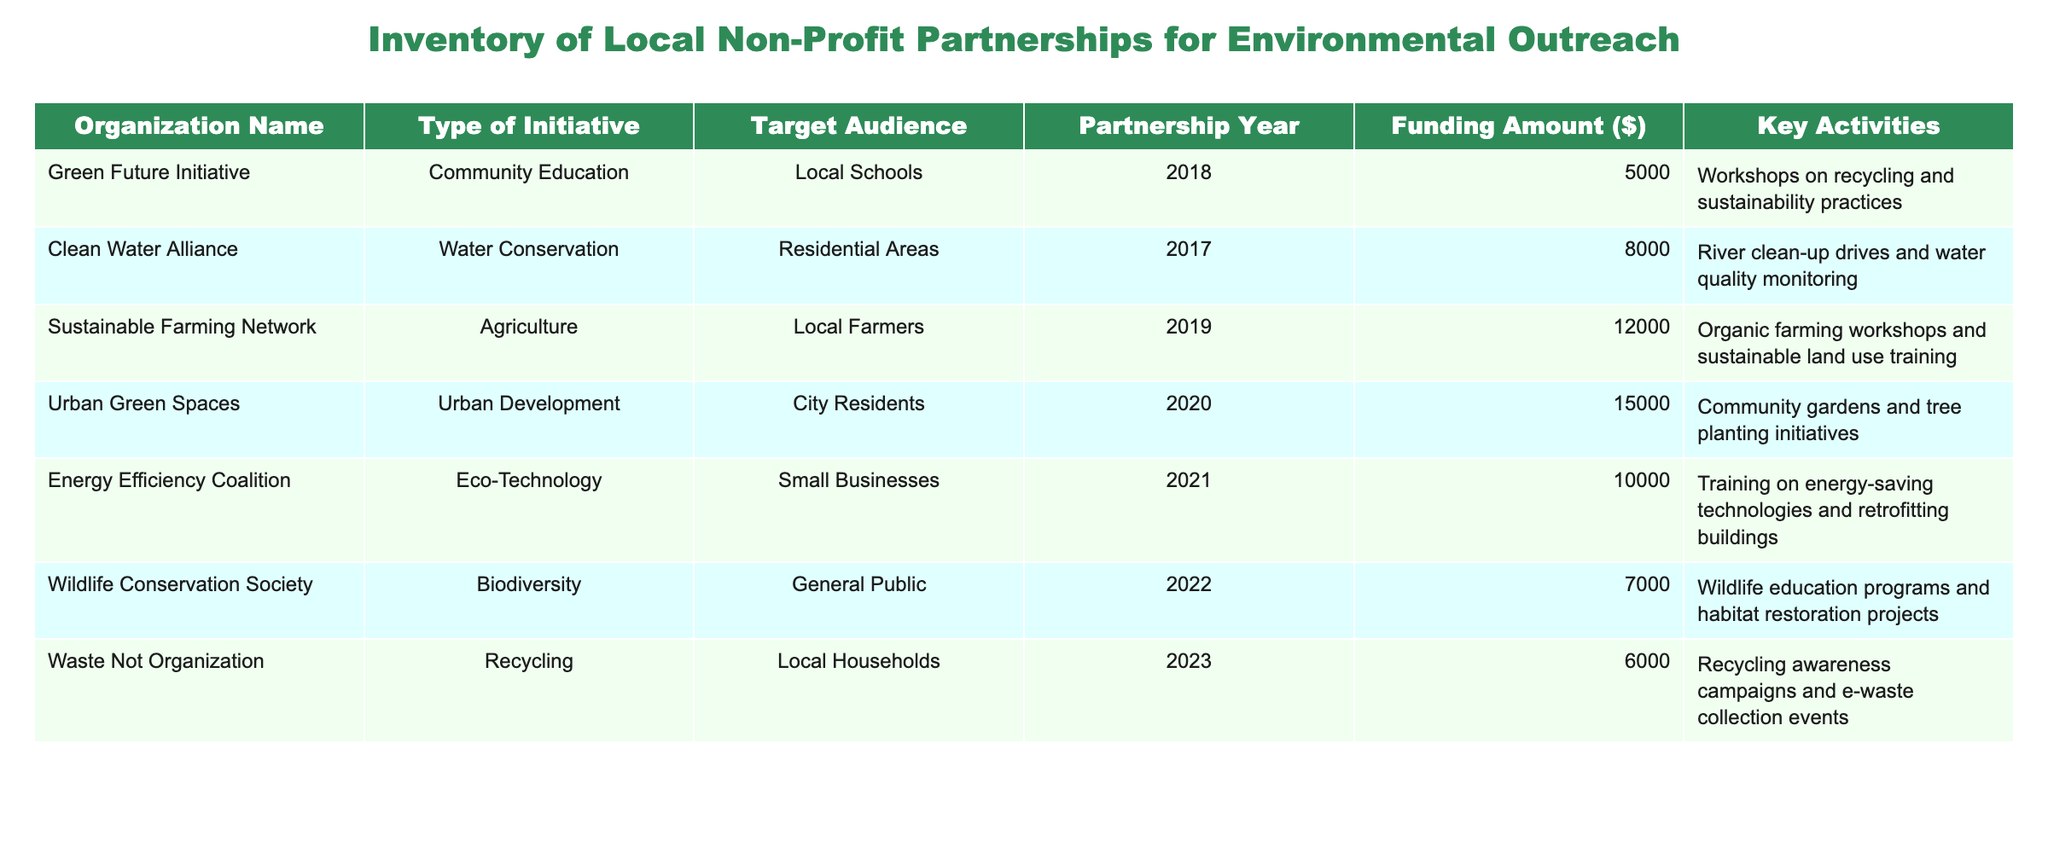What type of initiative does the Sustainable Farming Network focus on? The table lists the types of initiatives under the "Type of Initiative" column. Looking for "Sustainable Farming Network," I see that its initiative is categorized as "Agriculture."
Answer: Agriculture Which organization received the highest funding amount? By examining the "Funding Amount ($)" column, Urban Green Spaces has the highest amount at 15000, which is greater than the amounts for the other organizations listed.
Answer: Urban Green Spaces How many organizations focus on community education? Checking the table under the "Type of Initiative" column, I find only one organization, the Green Future Initiative, which focuses on "Community Education."
Answer: 1 What is the average funding amount for all organizations listed? To find the average, first, sum the funding amounts: 5000 + 8000 + 12000 + 15000 + 10000 + 7000 + 6000 = 60000. Then divide by the number of organizations (7): 60000 / 7 = 8571.43.
Answer: 8571.43 Did any organization partner in 2022? Scanning the "Partnership Year" column, I find that the Wildlife Conservation Society partnered in 2022, confirming that an organization did indeed partner that year.
Answer: Yes Which target audience was addressed by the Clean Water Alliance? Referring to the "Target Audience" column while finding "Clean Water Alliance," it is listed as targeting "Residential Areas."
Answer: Residential Areas What are the key activities of the Waste Not Organization? Looking at the Key Activities column for the Waste Not Organization, it mentions "Recycling awareness campaigns and e-waste collection events," which describes its actions.
Answer: Recycling awareness campaigns and e-waste collection events Is there an organization focusing on eco-technology initiatives? Checking the "Type of Initiative" column, I see that the Energy Efficiency Coalition is listed under "Eco-Technology," indicating that there is an organization with this focus.
Answer: Yes What is the total funding received by initiatives focused on environmental education? First, identify relevant initiatives: Green Future Initiative ($5000) and Wildlife Conservation Society ($7000). Summing these gives 5000 + 7000 = 12000.
Answer: 12000 